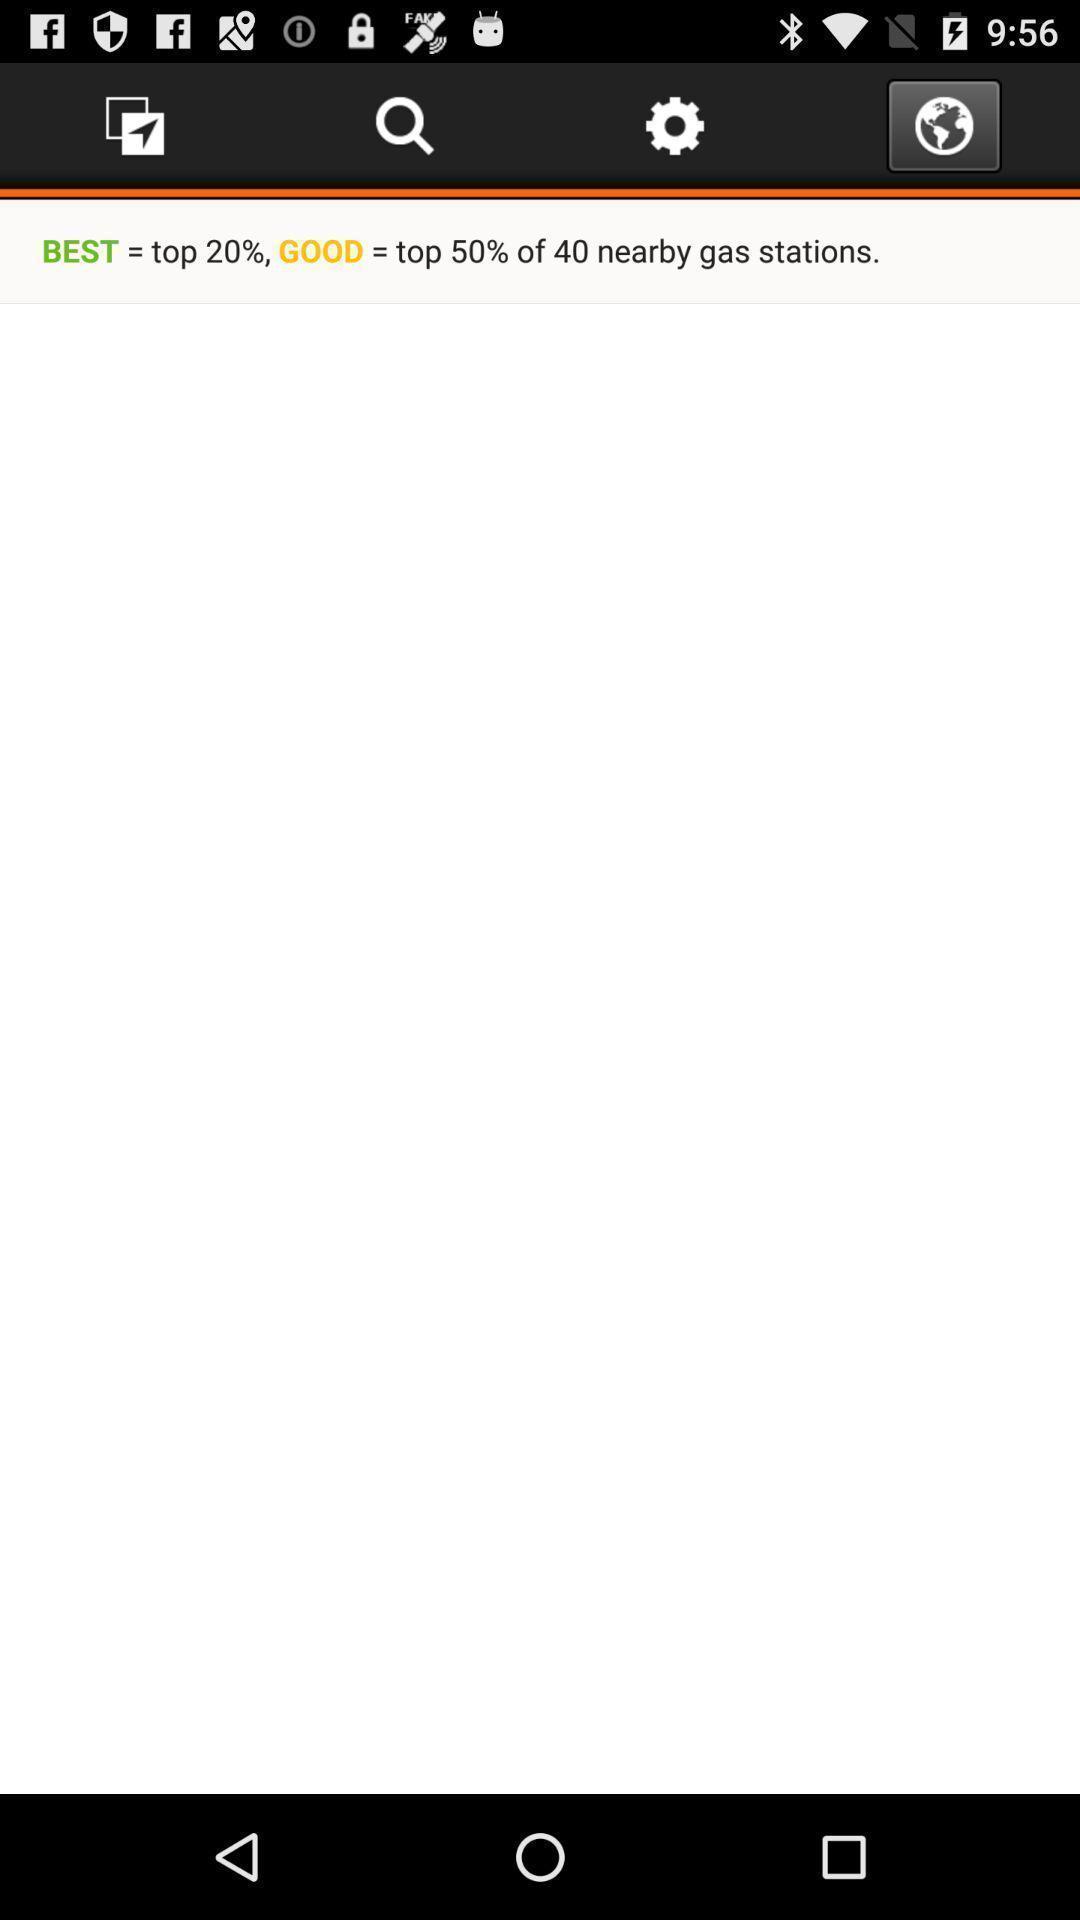Provide a description of this screenshot. Page displaying the offers of a browser. 